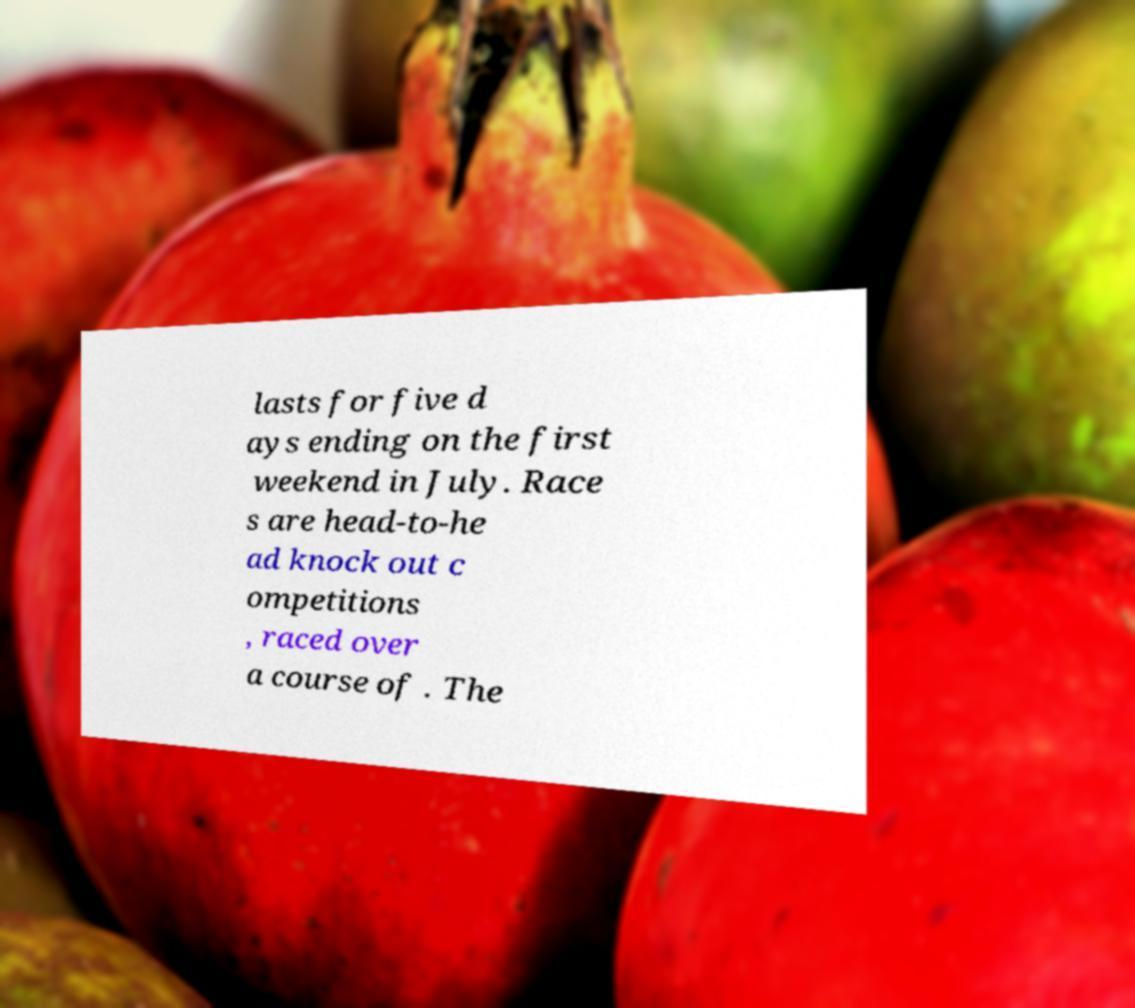Could you assist in decoding the text presented in this image and type it out clearly? lasts for five d ays ending on the first weekend in July. Race s are head-to-he ad knock out c ompetitions , raced over a course of . The 